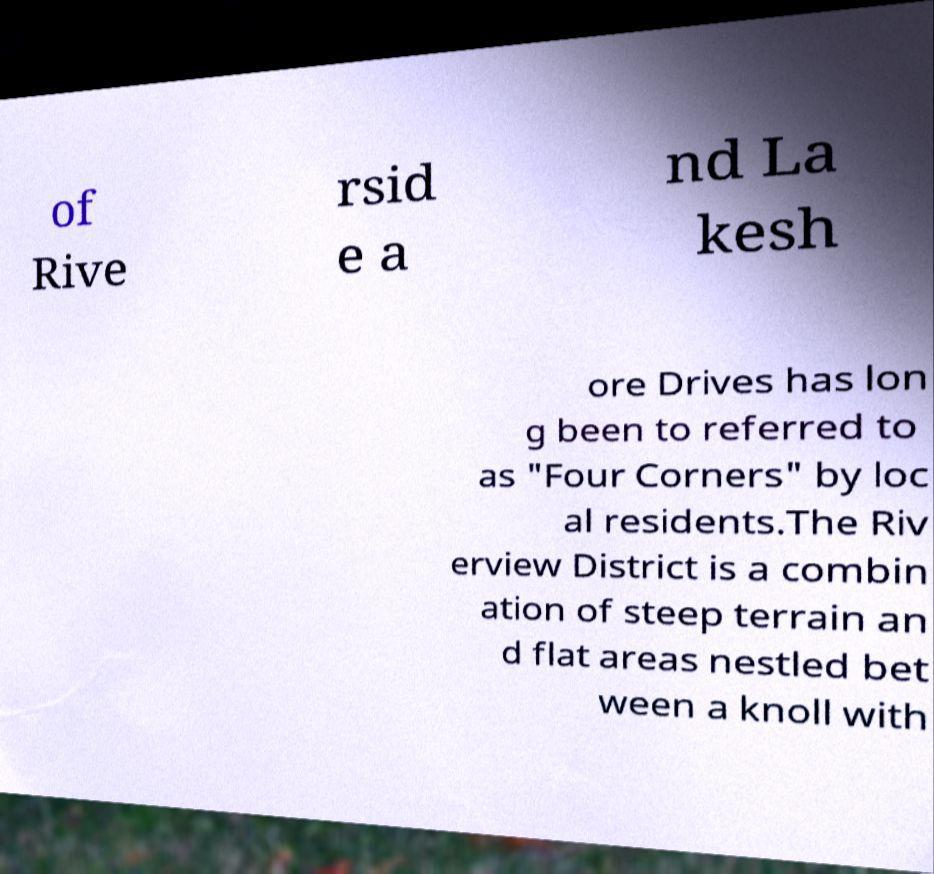Could you assist in decoding the text presented in this image and type it out clearly? of Rive rsid e a nd La kesh ore Drives has lon g been to referred to as "Four Corners" by loc al residents.The Riv erview District is a combin ation of steep terrain an d flat areas nestled bet ween a knoll with 